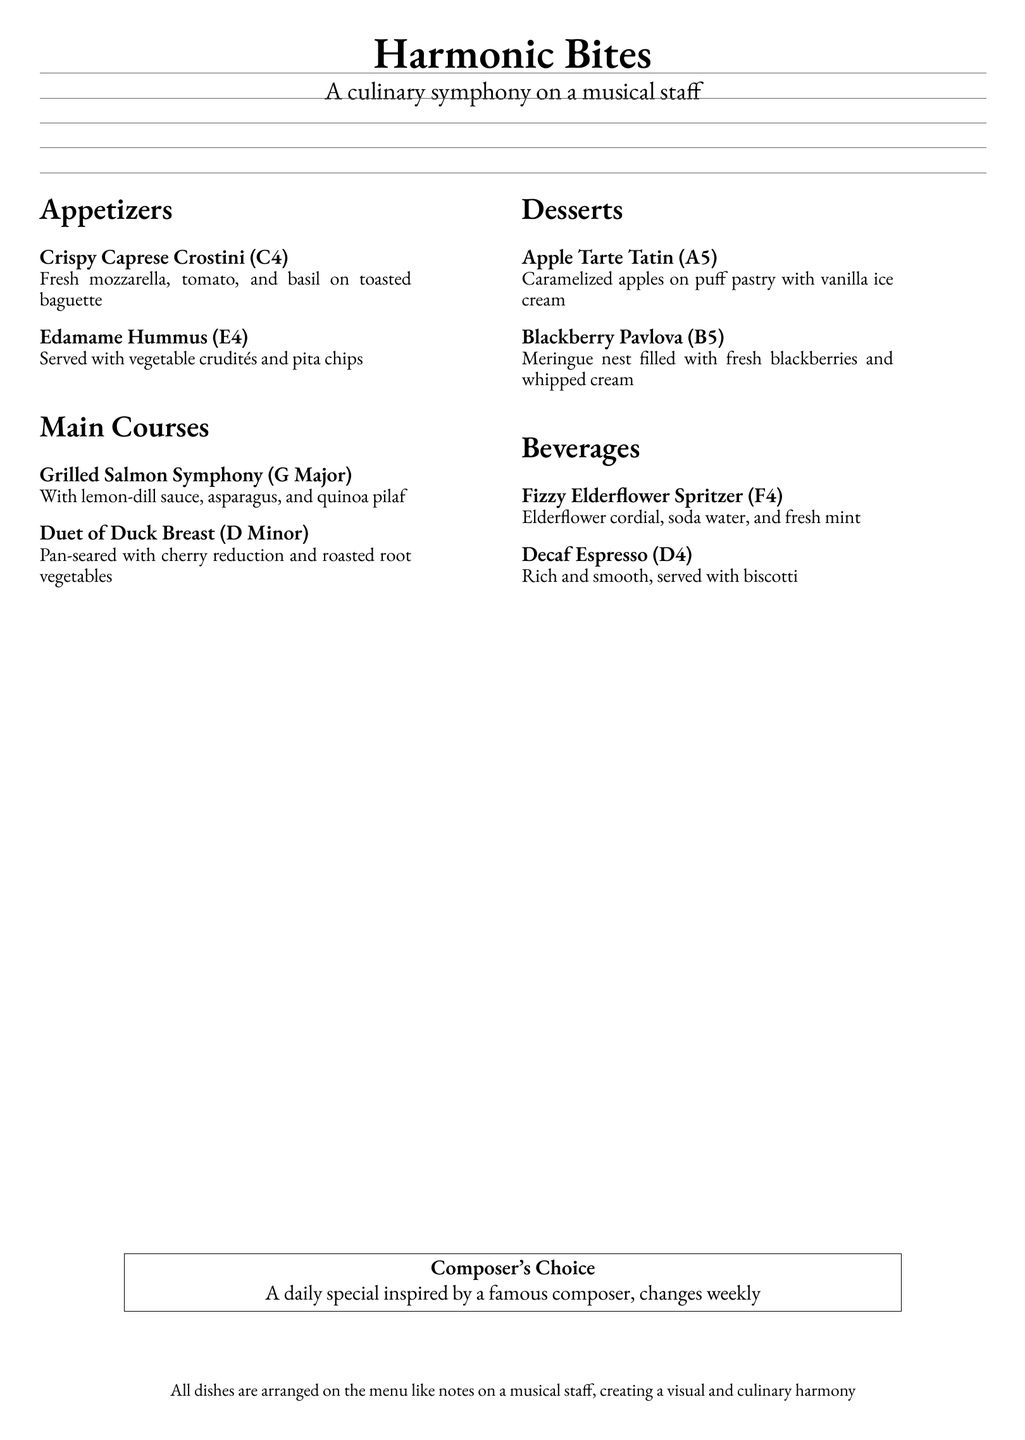What is the name of the restaurant? The name of the restaurant is presented at the top of the document as "Harmonic Bites."
Answer: Harmonic Bites How many sections are there in the menu? The menu contains four sections: Appetizers, Main Courses, Desserts, and Beverages.
Answer: Four What musical note corresponds to the Crispy Caprese Crostini? The document indicates that the Crispy Caprese Crostini is labeled with the note C4.
Answer: C4 What is the main ingredient in the Edamame Hummus? The Edamame Hummus is served with vegetable crudités and pita chips as indicated in the description.
Answer: Edamame Which dessert features caramelized apples? The menu specifically lists the Apple Tarte Tatin as the dessert that includes caramelized apples.
Answer: Apple Tarte Tatin What is the title of the daily special? The document mentions that the daily special is referred to as "Composer's Choice."
Answer: Composer's Choice Which beverage is described as rich and smooth? The beverage described as rich and smooth is Decaf Espresso in the menu.
Answer: Decaf Espresso What musical key is associated with the Grilled Salmon Symphony? The description links the Grilled Salmon Symphony to the musical key of G Major.
Answer: G Major What is the primary visual theme of the menu? The primary visual theme of the menu is creating harmony, illustrated with dishes arranged like notes on a musical staff.
Answer: Culinary harmony 